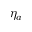<formula> <loc_0><loc_0><loc_500><loc_500>\eta _ { a }</formula> 